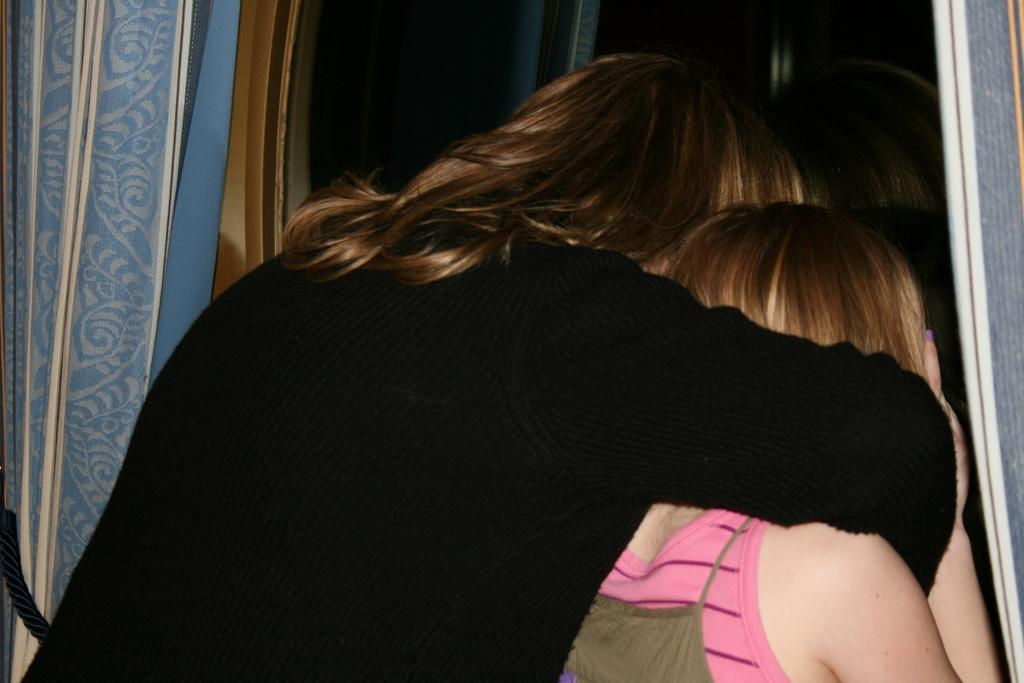How many people are in the image? There are two women in the image. What are the women doing in the image? The women are standing over a place and peeping through a window. What can be seen on either side of the window? Window curtains are present on either side of the window. What type of snow can be seen on the women's boots in the image? There are no boots or snow present in the image. 